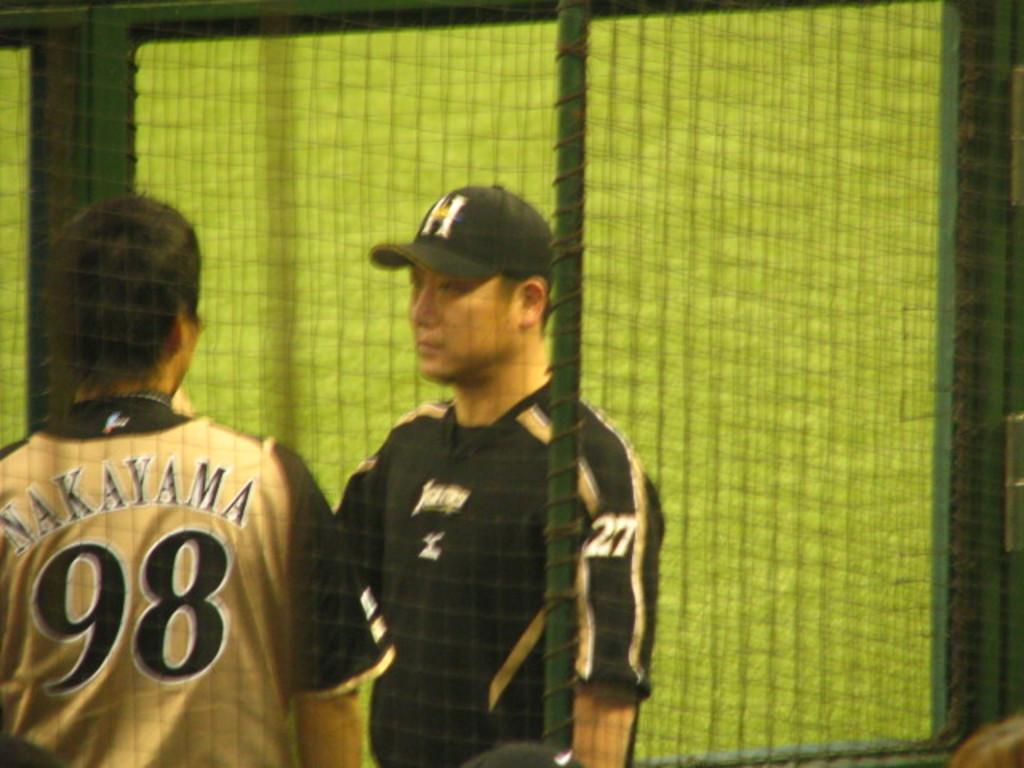What is the number on the man on the rights arm?
Ensure brevity in your answer.  27. What number is on the player's jersey on the left?
Your response must be concise. 98. 